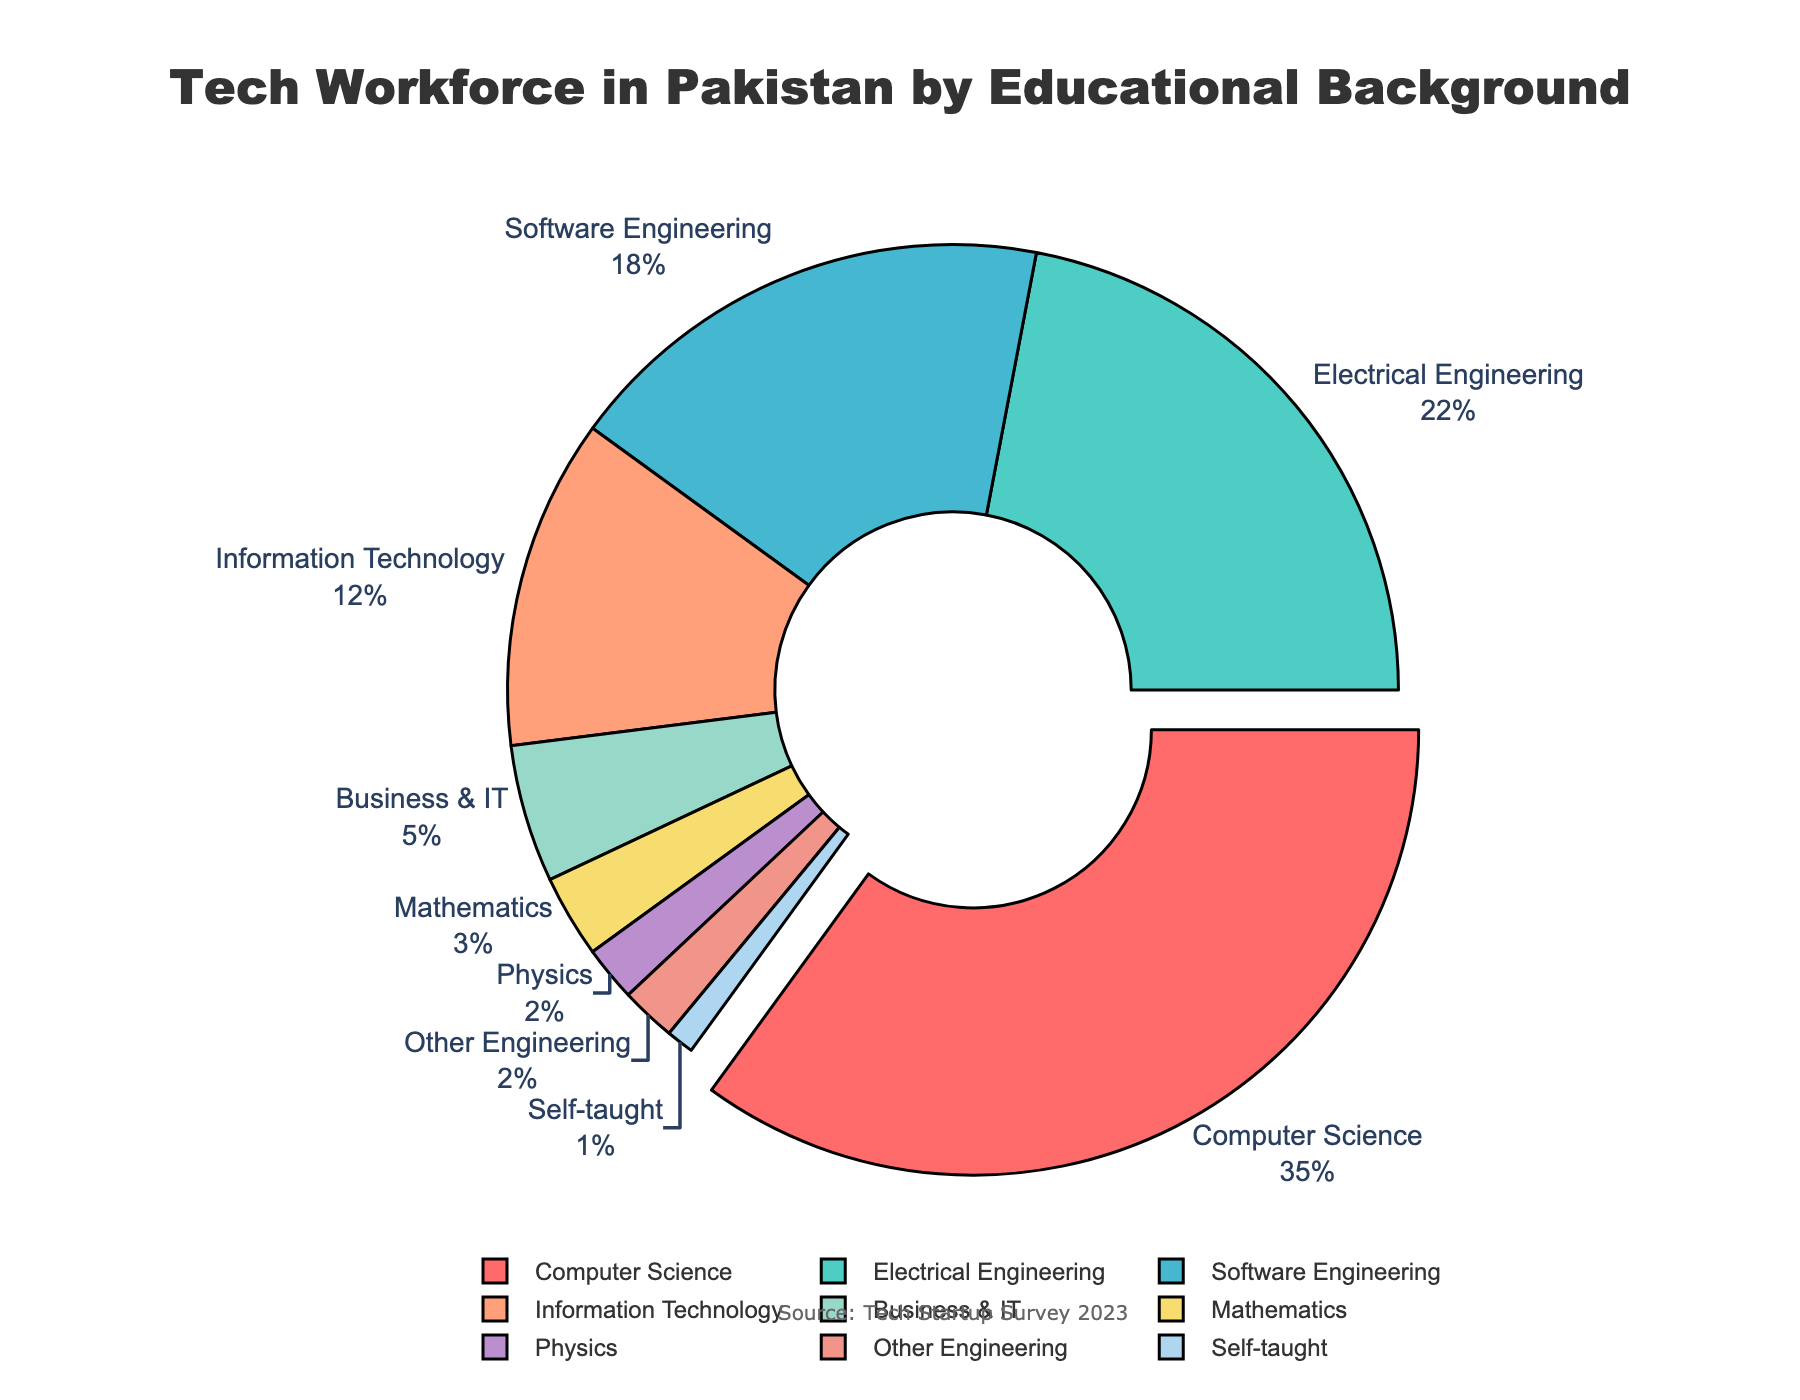Which educational background has the highest percentage in the tech workforce in Pakistan? The slice with the largest size represents the category with the highest percentage. The colored parts of the pie chart show that Computer Science has the highest percentage at 35%.
Answer: Computer Science What is the combined percentage of the tech workforce with a background in Software Engineering and Information Technology? To find this, add the percentage of Software Engineering (18%) to that of Information Technology (12%). The combined percentage is 18% + 12% = 30%.
Answer: 30% Which educational background category has more representation: Business & IT or Mathematics? From the pie chart, we observe the slices for Business & IT (5%) and Mathematics (3%). Since 5% is greater than 3%, Business & IT has more representation than Mathematics.
Answer: Business & IT How much larger is the Computer Science slice compared to the Self-taught slice in terms of percentage? The percentage for Computer Science is 35% and for Self-taught is 1%. To find the difference, subtract 1% from 35%, resulting in 35% - 1% = 34%.
Answer: 34% If you were to combine all engineering-related backgrounds (excluding Computer and Software Engineering), what would be their total percentage? Combine Electrical Engineering (22%) and Other Engineering (2%). The total percentage is 22% + 2% = 24%.
Answer: 24% Which category is represented by a dark green slice? Dark green is used to visualize Electrical Engineering. Looking at the colored parts in the pie chart, the dark green slice represents Electrical Engineering.
Answer: Electrical Engineering How does the representation of Information Technology compare to that of Electrical Engineering? The percentage for Information Technology is 12% and for Electrical Engineering is 22%. Since 12% is less than 22%, Information Technology has a smaller representation compared to Electrical Engineering.
Answer: Less What percentage of the workforce comes from non-engineering backgrounds, excluding Computer Science? We need to sum the percentages of Information Technology (12%), Business & IT (5%), Mathematics (3%), Physics (2%), and Self-taught (1%). The total is 12% + 5% + 3% + 2% + 1% = 23%.
Answer: 23% What is the difference in percentage between the highest and lowest represented educational backgrounds? The highest represented is Computer Science at 35%, and the lowest is Self-taught at 1%. The difference is 35% - 1% = 34%.
Answer: 34% What is the total percentage for all educational backgrounds represented in the pie chart? Summing up all the percentages: 35% + 22% + 18% + 12% + 5% + 3% + 2% + 2% + 1% = 100%. Since this is a pie chart, the total should be 100%.
Answer: 100% 